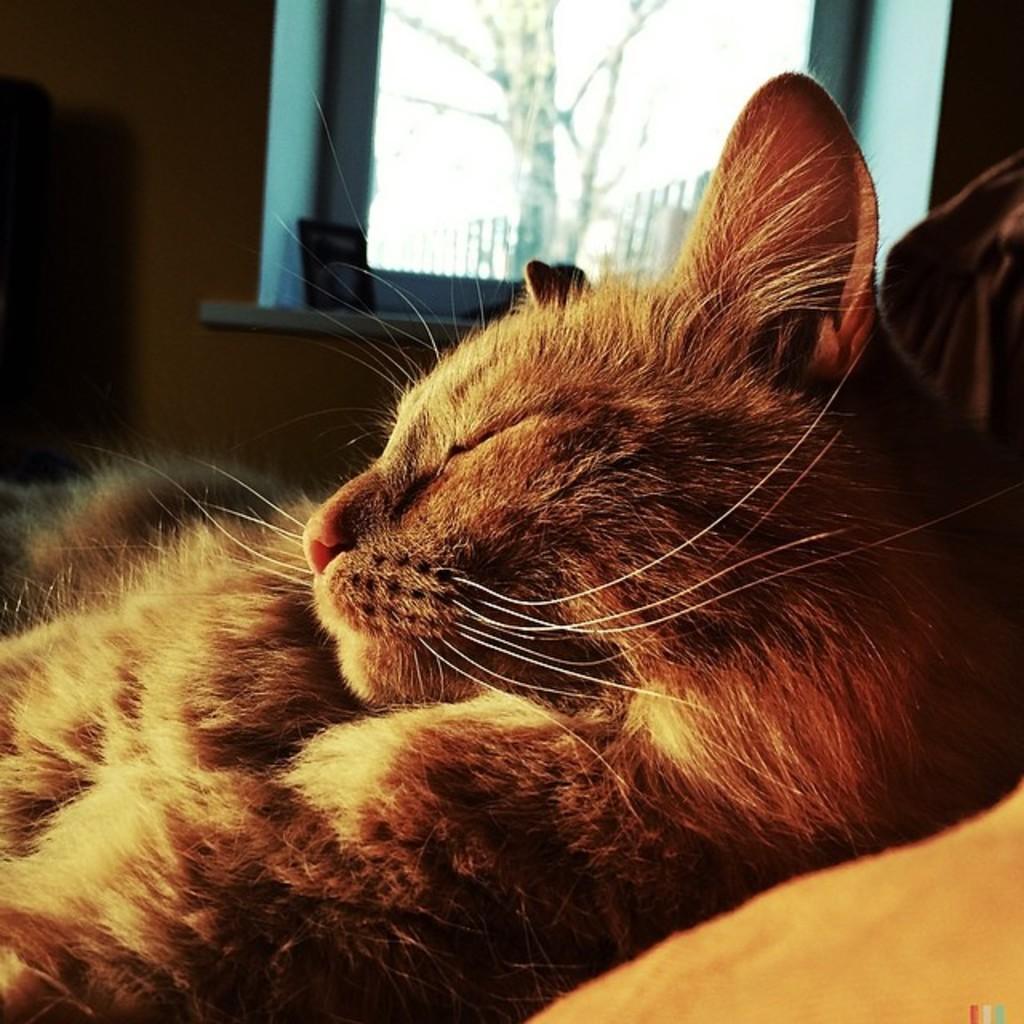Can you describe this image briefly? In this image we can see an animal in a room and in the background, we can see a wall with a window and there are some objects and we can see a tree outside the window. 